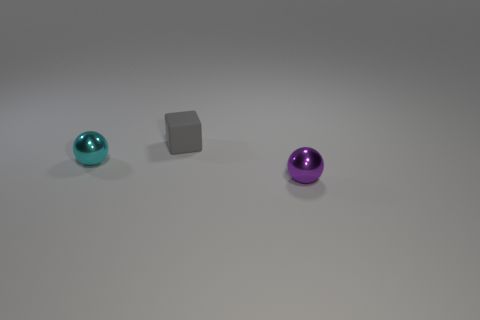What is the cyan ball made of? While I can't determine the exact material just from the image, the cyan ball appears to have a reflective surface, which could suggest that it's made of a polished metal or a similar synthetic material with a metallic finish. 